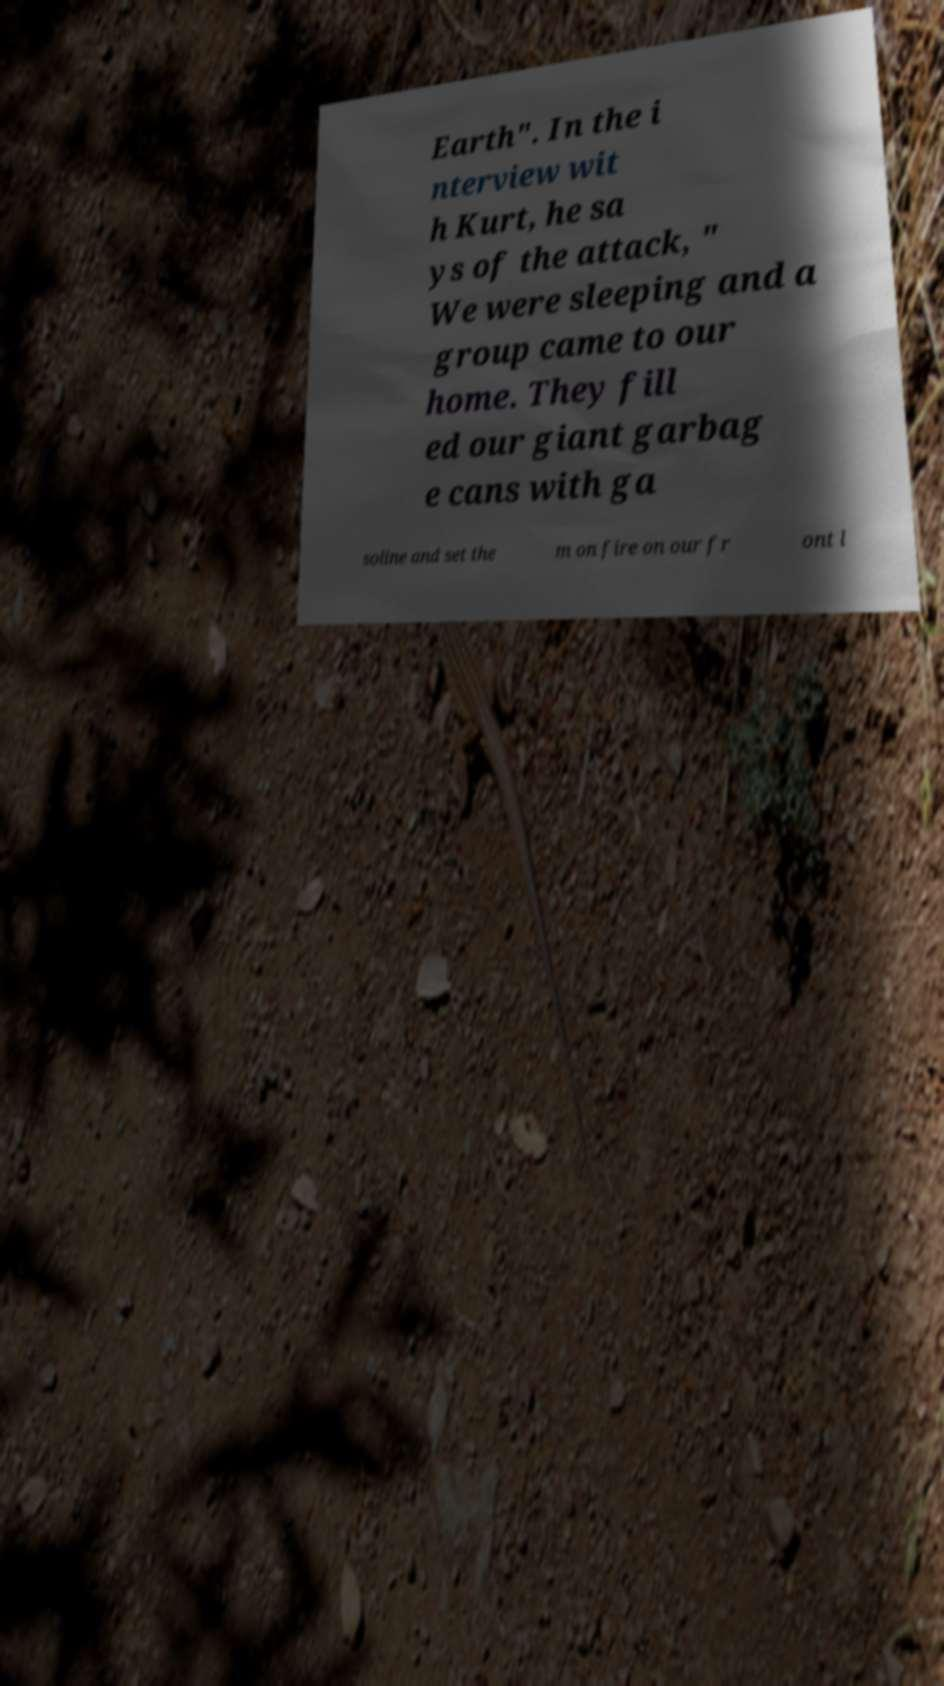Can you accurately transcribe the text from the provided image for me? Earth". In the i nterview wit h Kurt, he sa ys of the attack, " We were sleeping and a group came to our home. They fill ed our giant garbag e cans with ga soline and set the m on fire on our fr ont l 